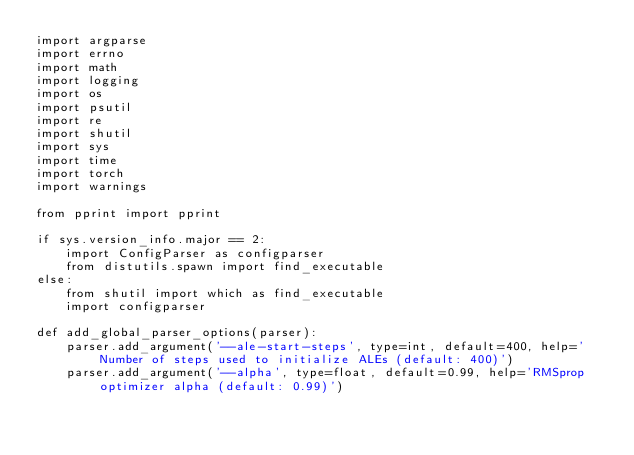<code> <loc_0><loc_0><loc_500><loc_500><_Python_>import argparse
import errno
import math
import logging
import os
import psutil
import re
import shutil
import sys
import time
import torch
import warnings

from pprint import pprint

if sys.version_info.major == 2:
    import ConfigParser as configparser
    from distutils.spawn import find_executable
else:
    from shutil import which as find_executable
    import configparser

def add_global_parser_options(parser):
    parser.add_argument('--ale-start-steps', type=int, default=400, help='Number of steps used to initialize ALEs (default: 400)')
    parser.add_argument('--alpha', type=float, default=0.99, help='RMSprop optimizer alpha (default: 0.99)')</code> 